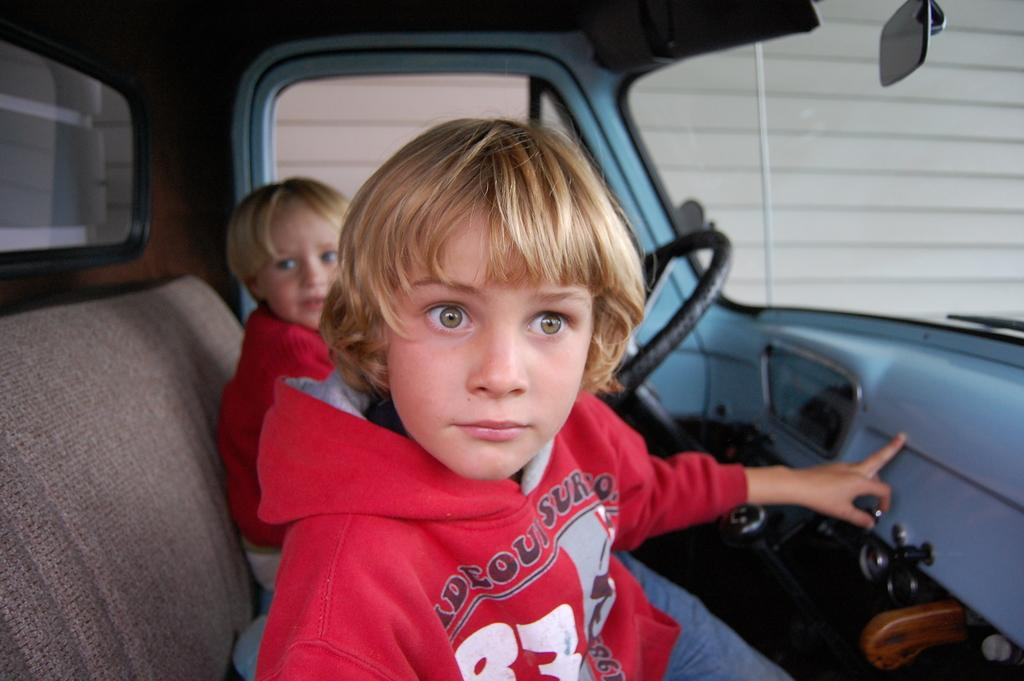How many kids are in the image? There are two kids in the image. Where are the kids located in the image? The kids are sitting inside a vehicle. What can be seen in the vehicle with the kids? There is a steering wheel in the vehicle. What is the color of the steering wheel? The steering wheel is black in color. Can you tell me how many letters are written on the yak in the image? There is no yak present in the image, and therefore no letters can be written on it. What type of shame is the vehicle experiencing in the image? There is no indication of shame experienced by the vehicle or the kids in the image. 